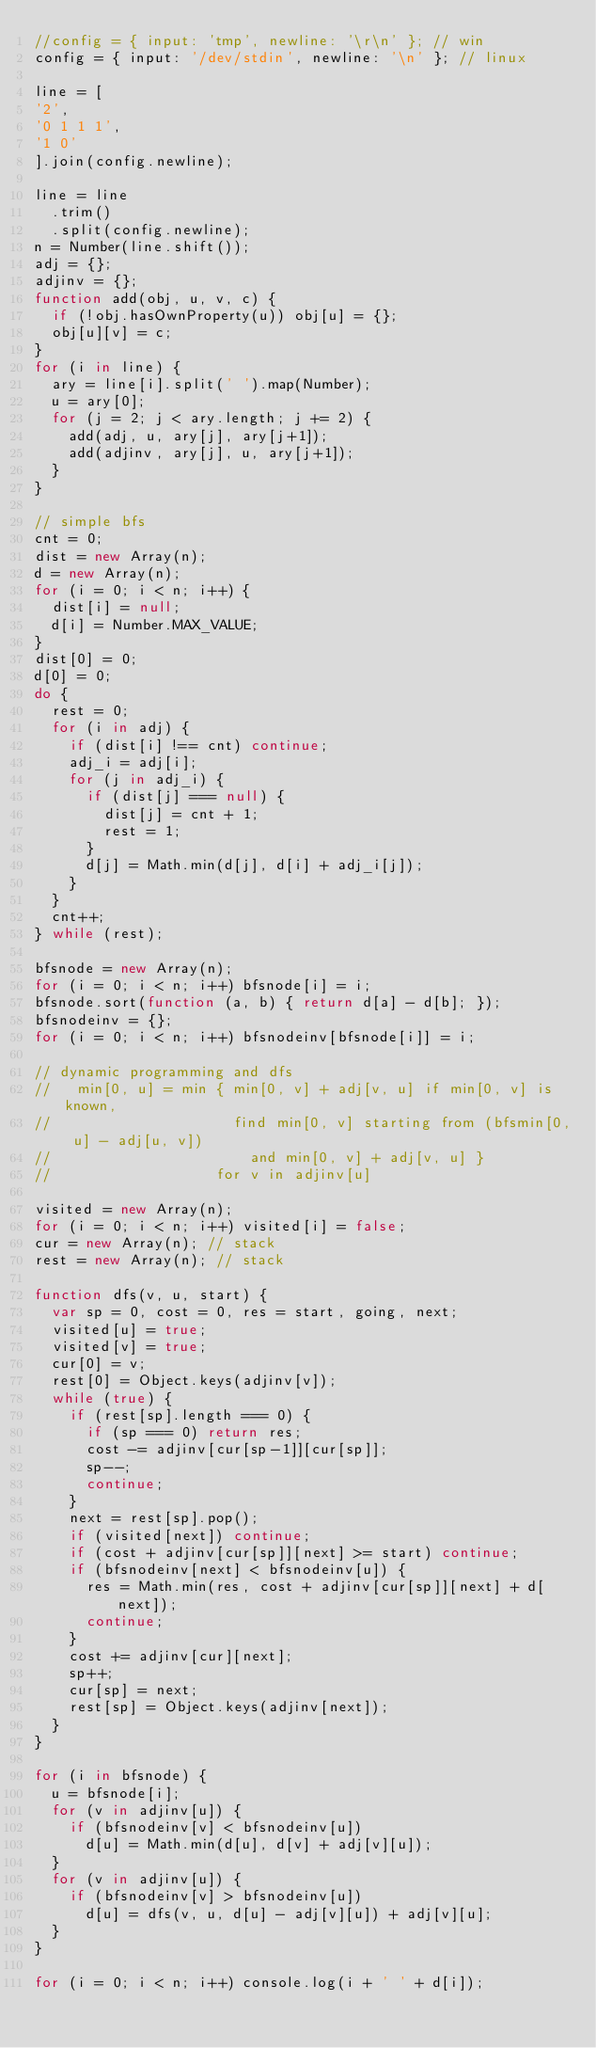Convert code to text. <code><loc_0><loc_0><loc_500><loc_500><_JavaScript_>//config = { input: 'tmp', newline: '\r\n' }; // win
config = { input: '/dev/stdin', newline: '\n' }; // linux

line = [
'2',
'0 1 1 1',
'1 0'
].join(config.newline);

line = line
  .trim()
  .split(config.newline);
n = Number(line.shift());
adj = {};
adjinv = {};
function add(obj, u, v, c) {
  if (!obj.hasOwnProperty(u)) obj[u] = {};
  obj[u][v] = c;
}
for (i in line) {
  ary = line[i].split(' ').map(Number);
  u = ary[0];
  for (j = 2; j < ary.length; j += 2) {
    add(adj, u, ary[j], ary[j+1]);
    add(adjinv, ary[j], u, ary[j+1]);
  }
}

// simple bfs
cnt = 0;
dist = new Array(n);
d = new Array(n);
for (i = 0; i < n; i++) {
  dist[i] = null;
  d[i] = Number.MAX_VALUE;
}
dist[0] = 0;
d[0] = 0;
do {
  rest = 0;
  for (i in adj) {
    if (dist[i] !== cnt) continue;
    adj_i = adj[i];
    for (j in adj_i) {
      if (dist[j] === null) {
        dist[j] = cnt + 1;
        rest = 1;
      }
      d[j] = Math.min(d[j], d[i] + adj_i[j]);
    }
  }
  cnt++;
} while (rest);

bfsnode = new Array(n);
for (i = 0; i < n; i++) bfsnode[i] = i;
bfsnode.sort(function (a, b) { return d[a] - d[b]; });
bfsnodeinv = {};
for (i = 0; i < n; i++) bfsnodeinv[bfsnode[i]] = i;

// dynamic programming and dfs
//   min[0, u] = min { min[0, v] + adj[v, u] if min[0, v] is known,
//                     find min[0, v] starting from (bfsmin[0, u] - adj[u, v])
//                       and min[0, v] + adj[v, u] }
//                   for v in adjinv[u]

visited = new Array(n);
for (i = 0; i < n; i++) visited[i] = false;
cur = new Array(n); // stack
rest = new Array(n); // stack

function dfs(v, u, start) {
  var sp = 0, cost = 0, res = start, going, next;
  visited[u] = true;
  visited[v] = true;
  cur[0] = v;
  rest[0] = Object.keys(adjinv[v]);
  while (true) {
    if (rest[sp].length === 0) {
      if (sp === 0) return res;
      cost -= adjinv[cur[sp-1]][cur[sp]];
      sp--;
      continue;
    }
    next = rest[sp].pop();
    if (visited[next]) continue;
    if (cost + adjinv[cur[sp]][next] >= start) continue;
    if (bfsnodeinv[next] < bfsnodeinv[u]) {
      res = Math.min(res, cost + adjinv[cur[sp]][next] + d[next]);
      continue;
    }
    cost += adjinv[cur][next];
    sp++;
    cur[sp] = next;
    rest[sp] = Object.keys(adjinv[next]);
  }
}

for (i in bfsnode) {
  u = bfsnode[i];
  for (v in adjinv[u]) {
    if (bfsnodeinv[v] < bfsnodeinv[u])
      d[u] = Math.min(d[u], d[v] + adj[v][u]);
  }
  for (v in adjinv[u]) {
    if (bfsnodeinv[v] > bfsnodeinv[u])
      d[u] = dfs(v, u, d[u] - adj[v][u]) + adj[v][u];
  }
}

for (i = 0; i < n; i++) console.log(i + ' ' + d[i]);</code> 